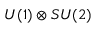<formula> <loc_0><loc_0><loc_500><loc_500>U ( 1 ) \otimes S U ( 2 )</formula> 